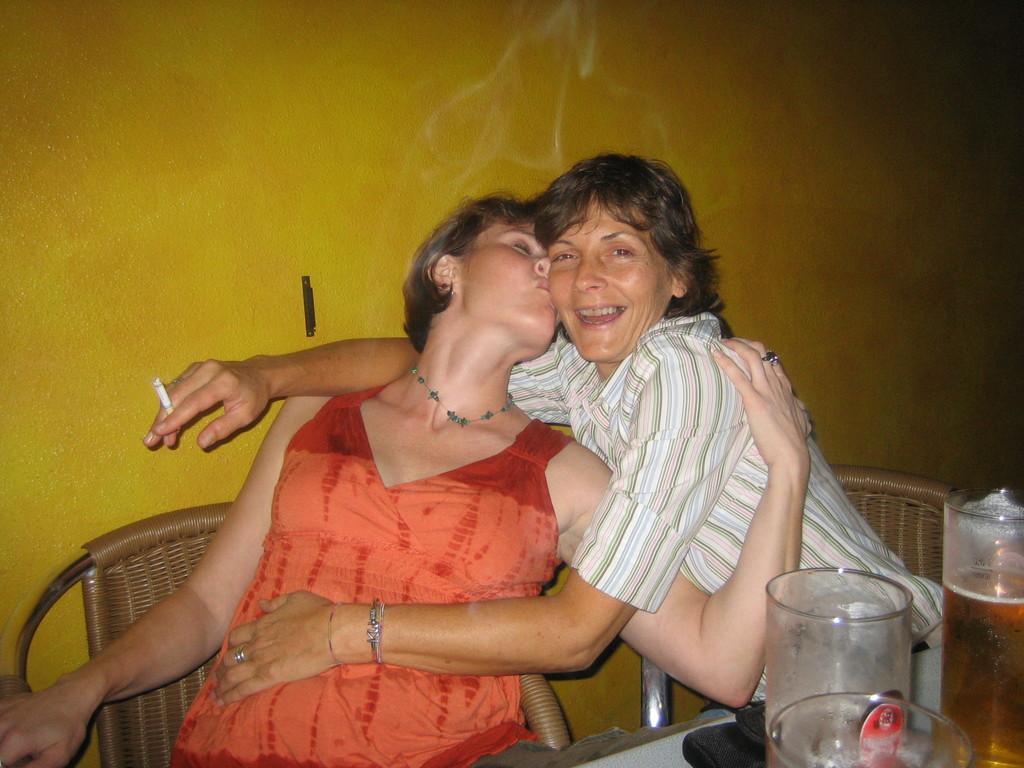Could you give a brief overview of what you see in this image? In this image, we can see a few people sitting on chairs. We can see a table with some objects like glasses. We can also see a black colored object. We can see the wall. 